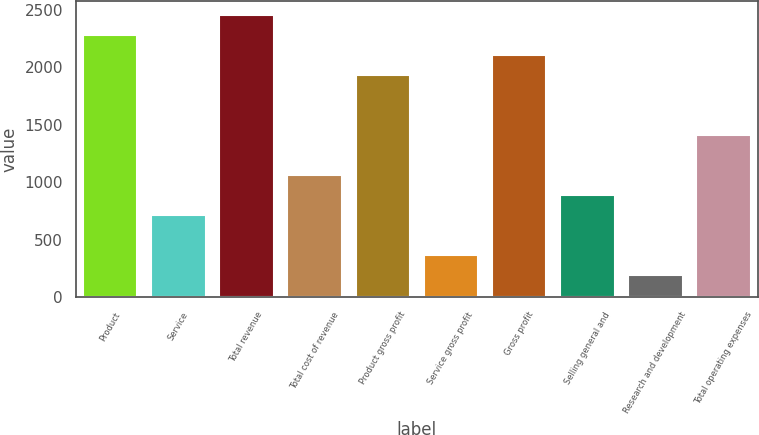Convert chart to OTSL. <chart><loc_0><loc_0><loc_500><loc_500><bar_chart><fcel>Product<fcel>Service<fcel>Total revenue<fcel>Total cost of revenue<fcel>Product gross profit<fcel>Service gross profit<fcel>Gross profit<fcel>Selling general and<fcel>Research and development<fcel>Total operating expenses<nl><fcel>2280.02<fcel>711.86<fcel>2454.26<fcel>1060.34<fcel>1931.54<fcel>363.38<fcel>2105.78<fcel>886.1<fcel>189.14<fcel>1408.82<nl></chart> 